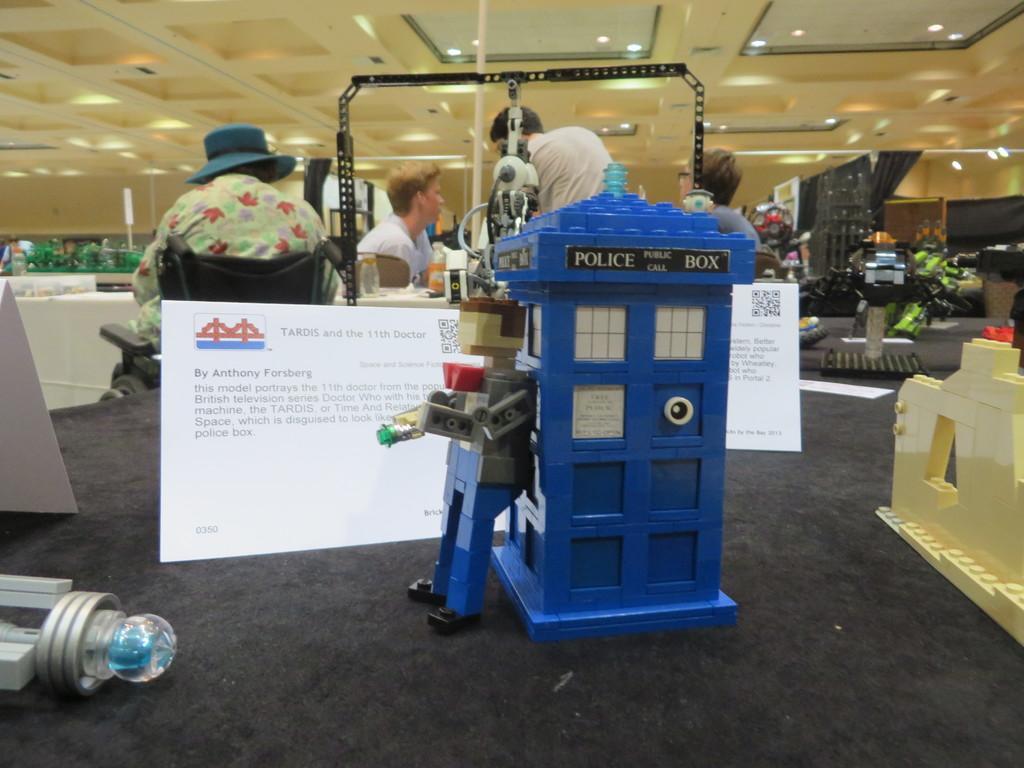How would you summarize this image in a sentence or two? There are toys and paper notes at the front. People are present and there are other objects. There are lights on the top. 